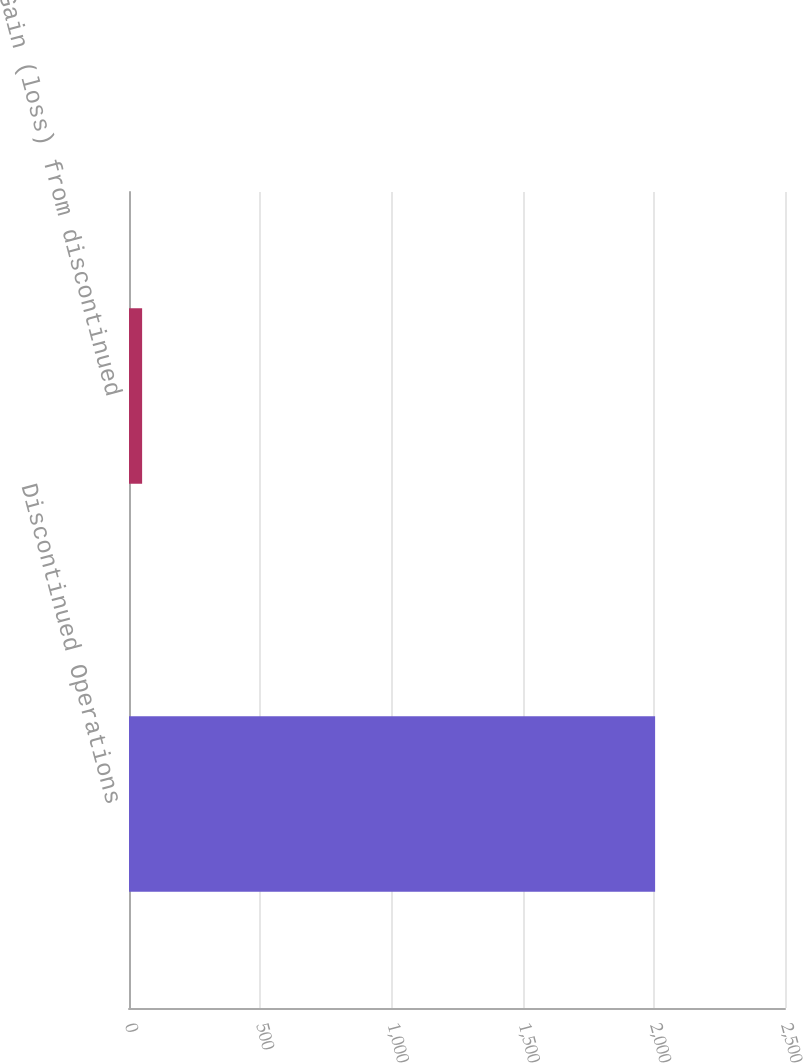Convert chart. <chart><loc_0><loc_0><loc_500><loc_500><bar_chart><fcel>Discontinued Operations<fcel>Gain (loss) from discontinued<nl><fcel>2005<fcel>50<nl></chart> 